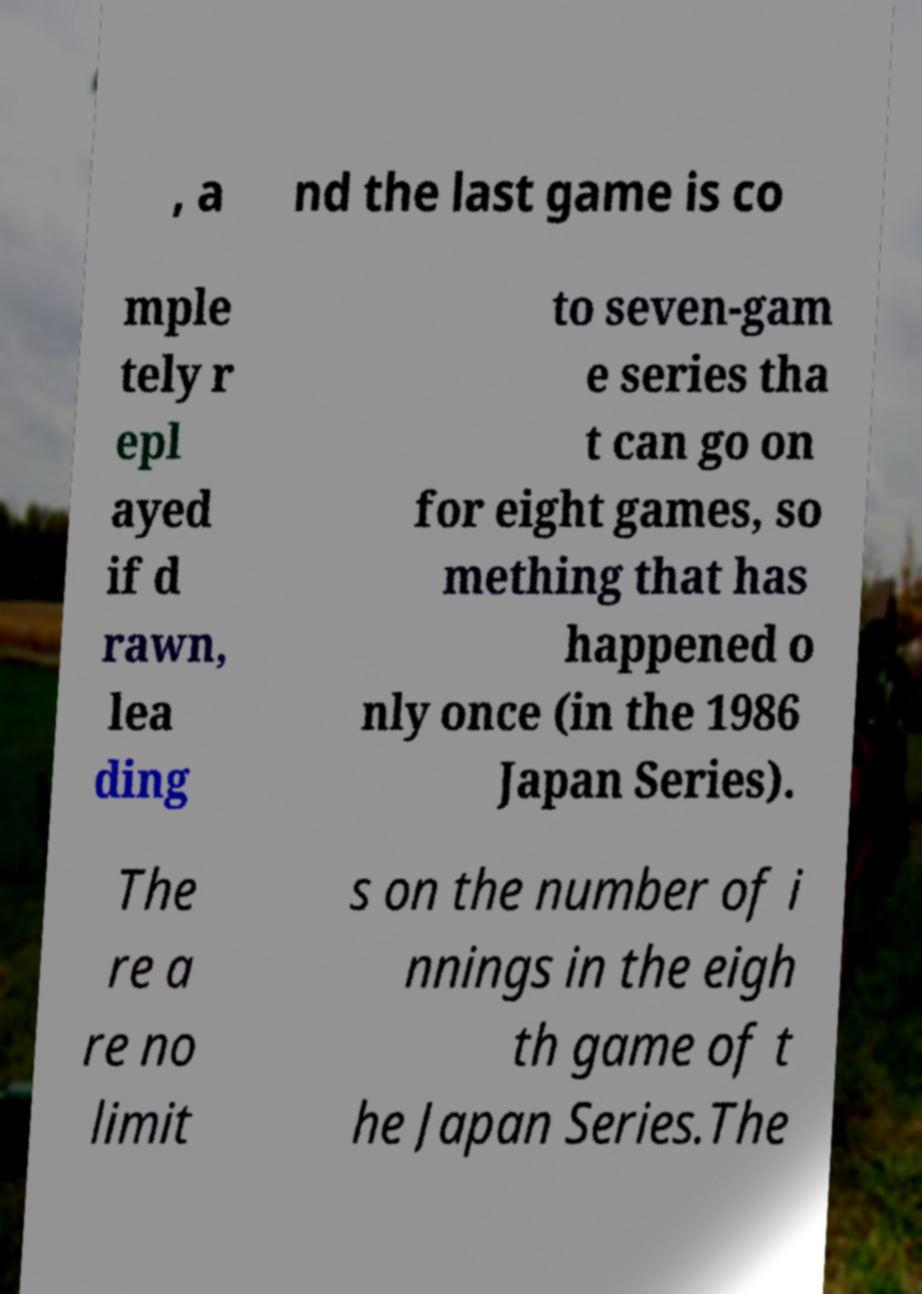Could you extract and type out the text from this image? , a nd the last game is co mple tely r epl ayed if d rawn, lea ding to seven-gam e series tha t can go on for eight games, so mething that has happened o nly once (in the 1986 Japan Series). The re a re no limit s on the number of i nnings in the eigh th game of t he Japan Series.The 